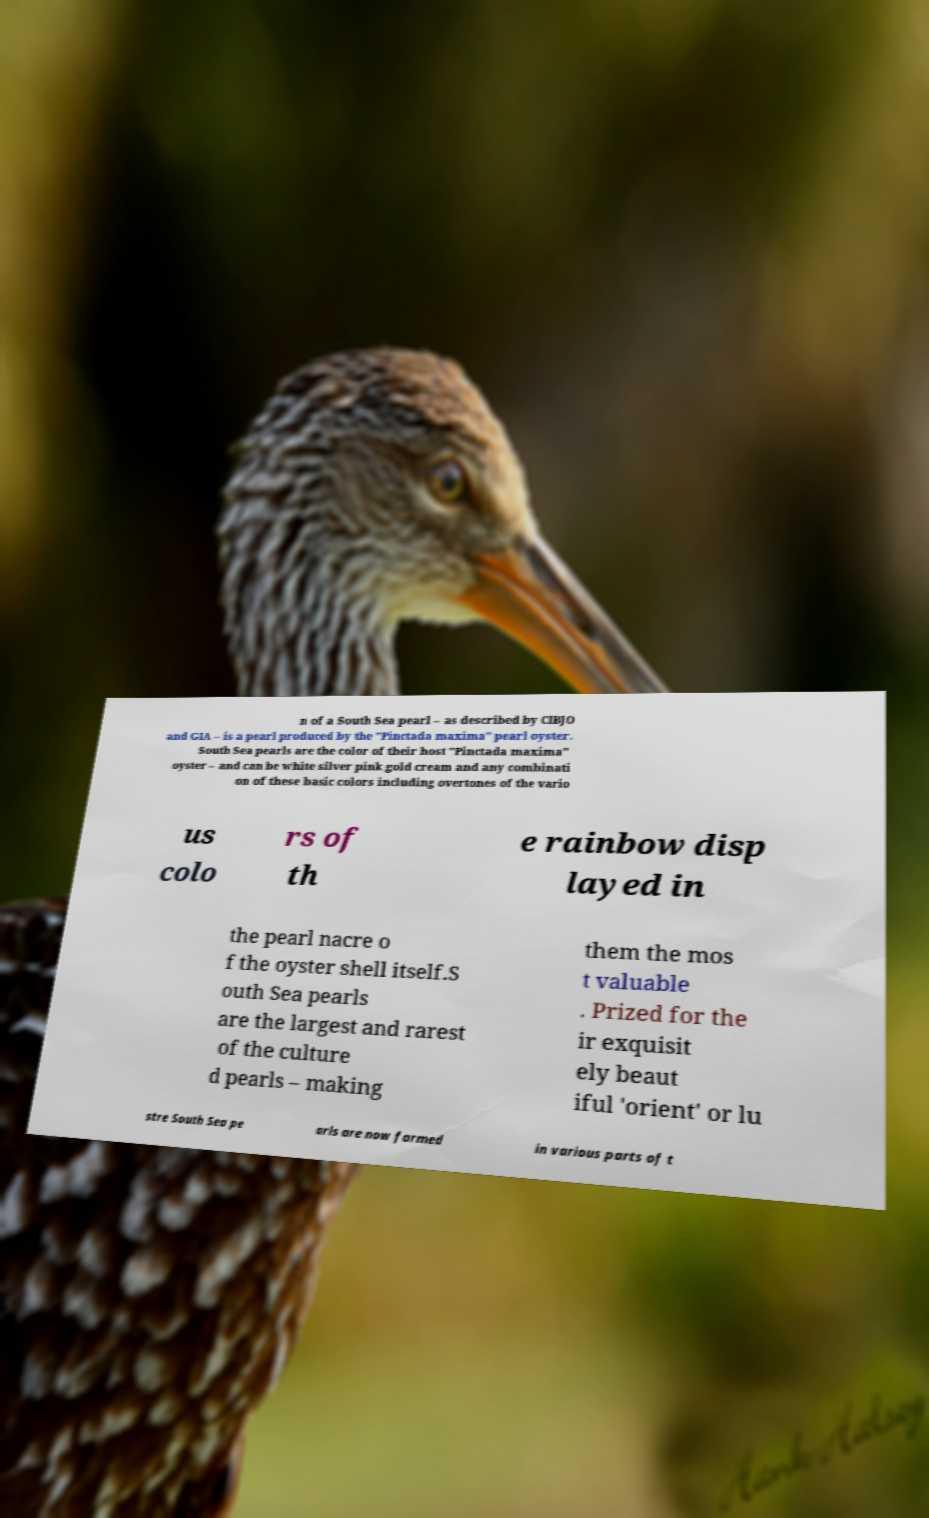For documentation purposes, I need the text within this image transcribed. Could you provide that? n of a South Sea pearl – as described by CIBJO and GIA – is a pearl produced by the "Pinctada maxima" pearl oyster. South Sea pearls are the color of their host "Pinctada maxima" oyster – and can be white silver pink gold cream and any combinati on of these basic colors including overtones of the vario us colo rs of th e rainbow disp layed in the pearl nacre o f the oyster shell itself.S outh Sea pearls are the largest and rarest of the culture d pearls – making them the mos t valuable . Prized for the ir exquisit ely beaut iful 'orient' or lu stre South Sea pe arls are now farmed in various parts of t 